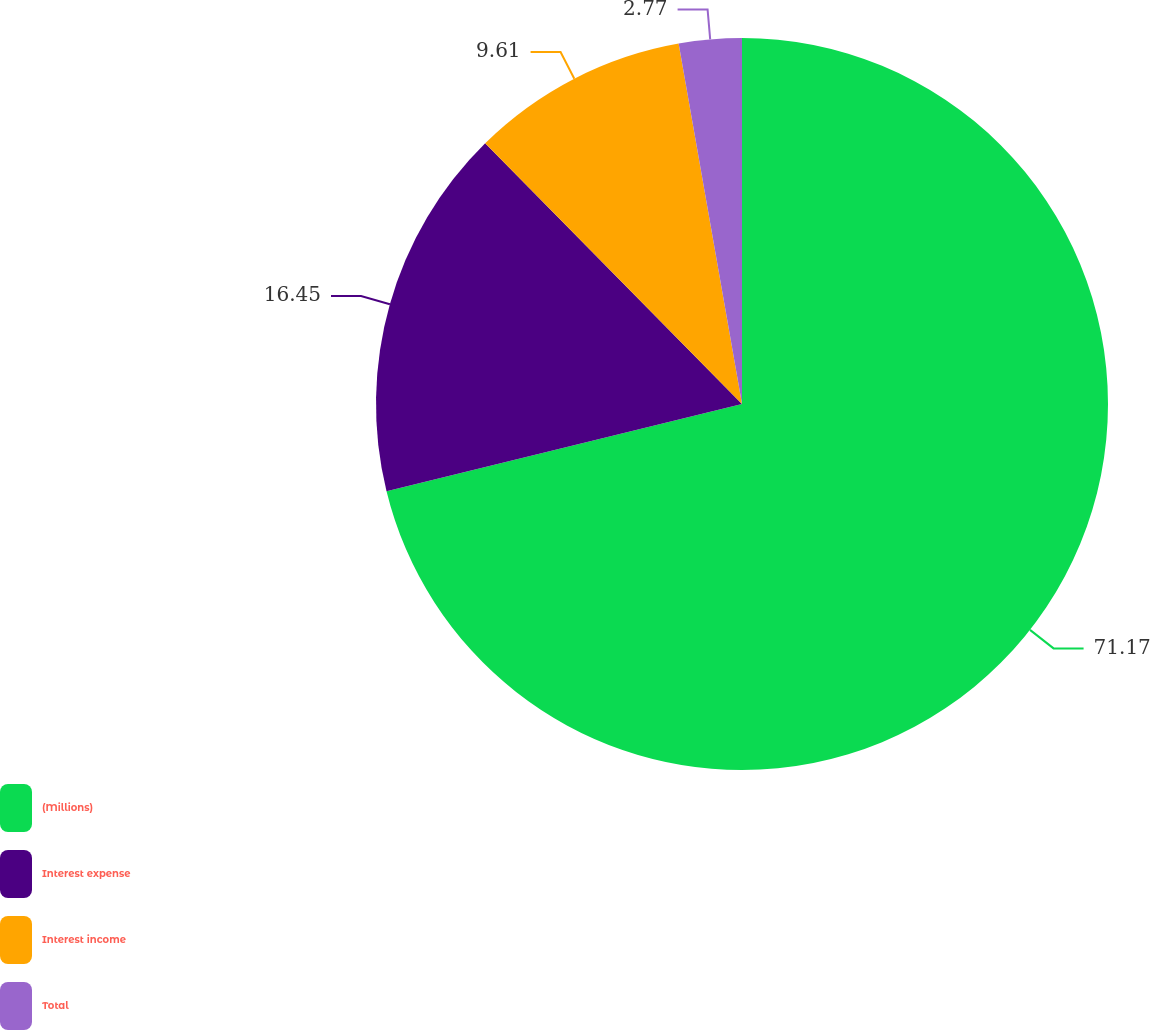Convert chart to OTSL. <chart><loc_0><loc_0><loc_500><loc_500><pie_chart><fcel>(Millions)<fcel>Interest expense<fcel>Interest income<fcel>Total<nl><fcel>71.18%<fcel>16.45%<fcel>9.61%<fcel>2.77%<nl></chart> 